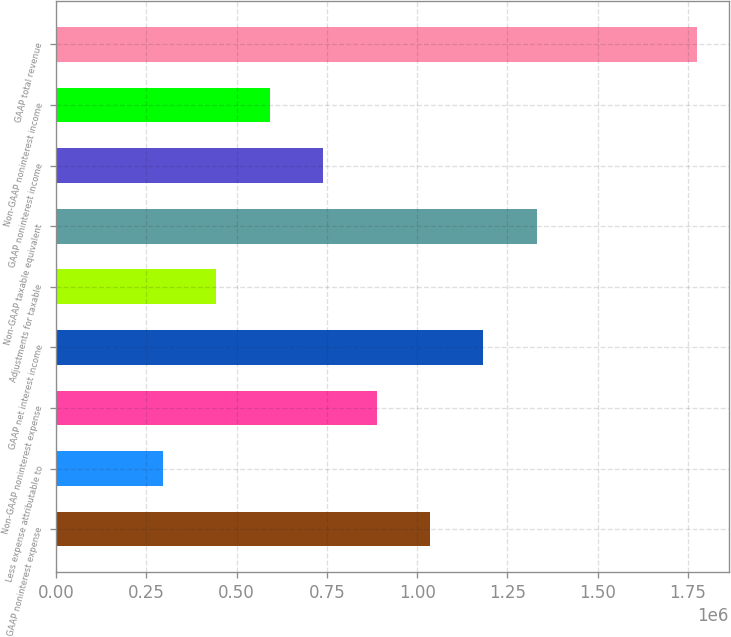Convert chart to OTSL. <chart><loc_0><loc_0><loc_500><loc_500><bar_chart><fcel>GAAP noninterest expense<fcel>Less expense attributable to<fcel>Non-GAAP noninterest expense<fcel>GAAP net interest income<fcel>Adjustments for taxable<fcel>Non-GAAP taxable equivalent<fcel>GAAP noninterest income<fcel>Non-GAAP noninterest income<fcel>GAAP total revenue<nl><fcel>1.03547e+06<fcel>295886<fcel>887553<fcel>1.18339e+06<fcel>443803<fcel>1.3313e+06<fcel>739636<fcel>591719<fcel>1.77505e+06<nl></chart> 